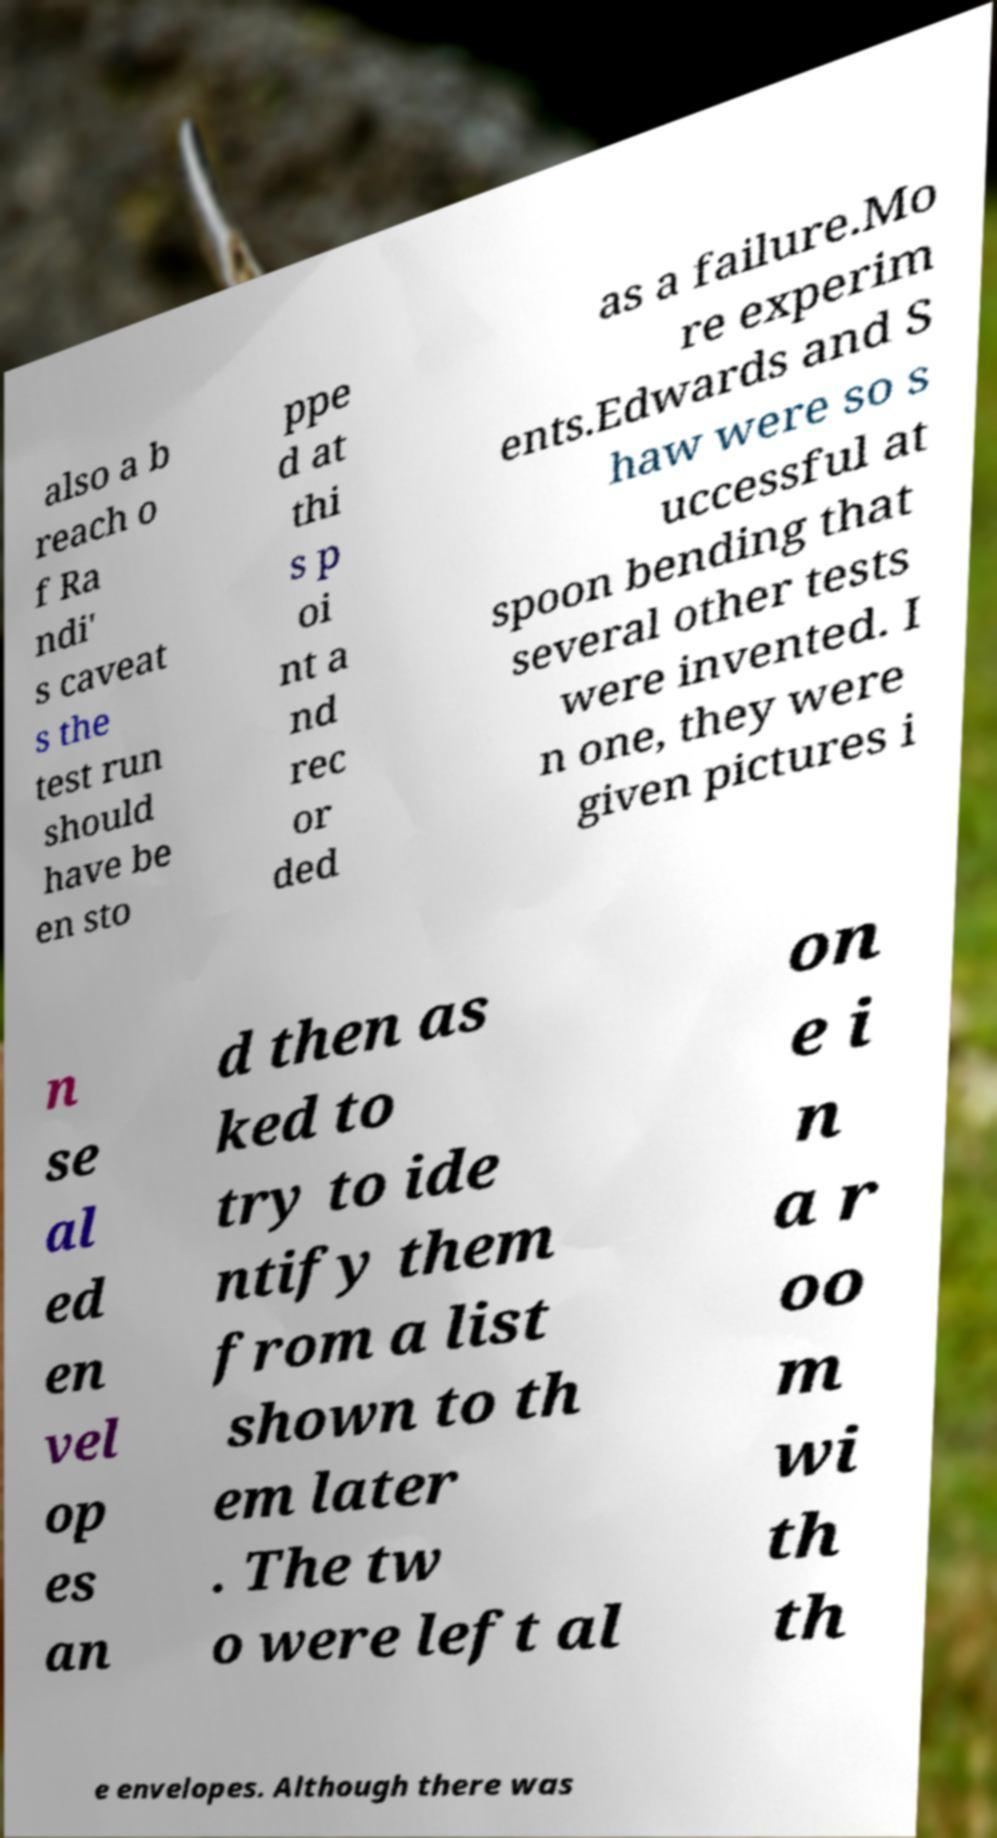For documentation purposes, I need the text within this image transcribed. Could you provide that? also a b reach o f Ra ndi' s caveat s the test run should have be en sto ppe d at thi s p oi nt a nd rec or ded as a failure.Mo re experim ents.Edwards and S haw were so s uccessful at spoon bending that several other tests were invented. I n one, they were given pictures i n se al ed en vel op es an d then as ked to try to ide ntify them from a list shown to th em later . The tw o were left al on e i n a r oo m wi th th e envelopes. Although there was 